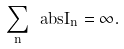Convert formula to latex. <formula><loc_0><loc_0><loc_500><loc_500>\sum _ { n } \ a b s { \tilde { I } _ { n } } = \infty .</formula> 